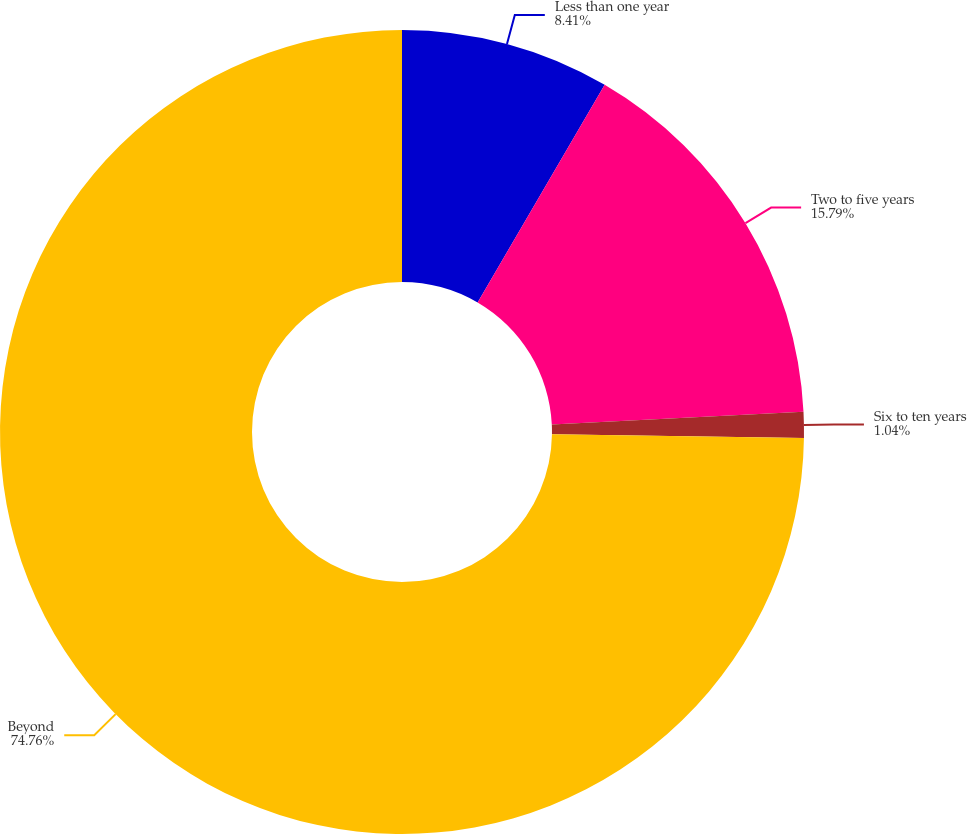<chart> <loc_0><loc_0><loc_500><loc_500><pie_chart><fcel>Less than one year<fcel>Two to five years<fcel>Six to ten years<fcel>Beyond<nl><fcel>8.41%<fcel>15.79%<fcel>1.04%<fcel>74.76%<nl></chart> 